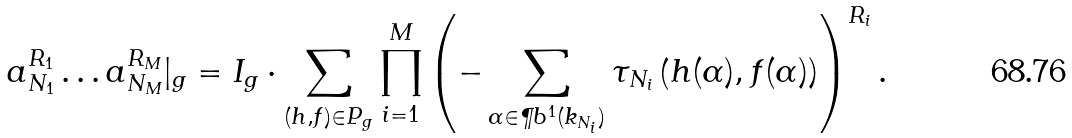Convert formula to latex. <formula><loc_0><loc_0><loc_500><loc_500>a _ { N _ { 1 } } ^ { R _ { 1 } } \dots a _ { N _ { M } } ^ { R _ { M } } | _ { g } = I _ { g } \cdot \sum _ { ( h , f ) \in P _ { g } } \prod _ { i = 1 } ^ { M } \left ( - \sum _ { \alpha \in \P b ^ { 1 } ( k _ { N _ { i } } ) } \tau _ { N _ { i } } \left ( h ( \alpha ) , f ( \alpha ) \right ) \right ) ^ { R _ { i } } .</formula> 